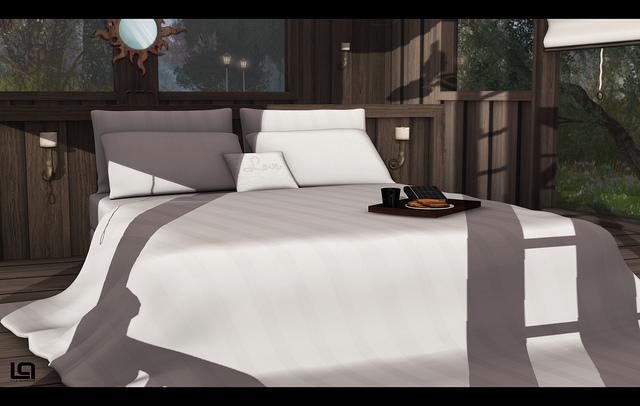Does this room appear to be clean?
Concise answer only. Yes. Is that a new sheet?
Answer briefly. Yes. Is someone sleeping?
Give a very brief answer. No. 